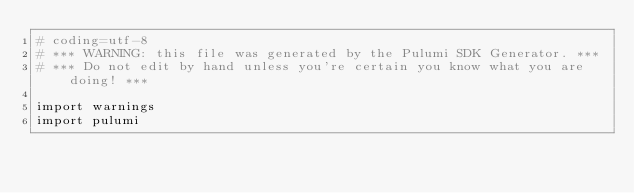Convert code to text. <code><loc_0><loc_0><loc_500><loc_500><_Python_># coding=utf-8
# *** WARNING: this file was generated by the Pulumi SDK Generator. ***
# *** Do not edit by hand unless you're certain you know what you are doing! ***

import warnings
import pulumi</code> 